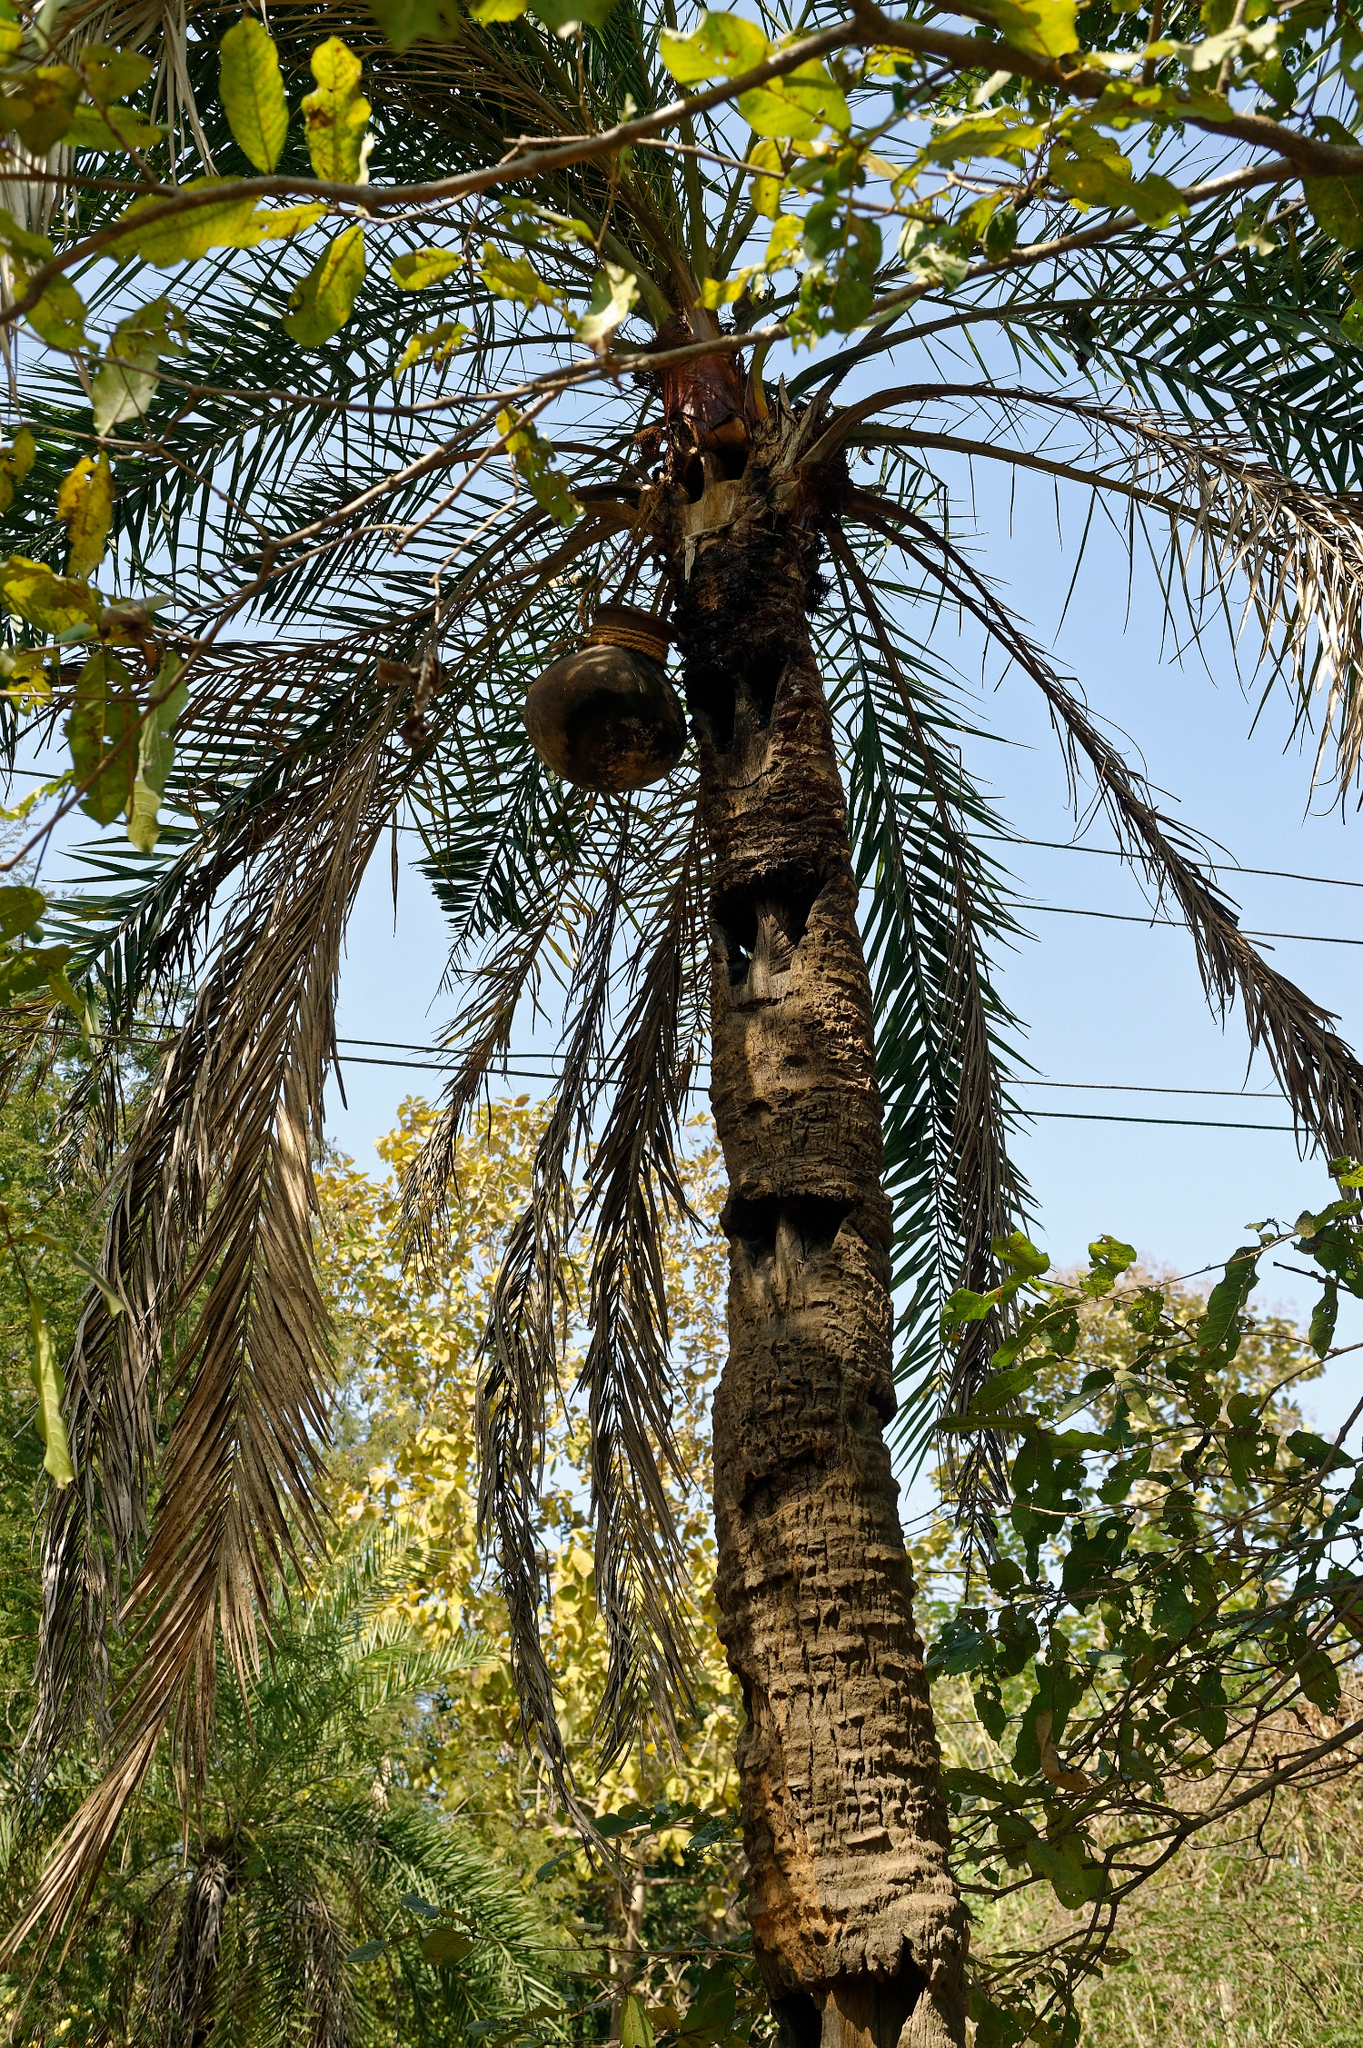Can you provide a story inspired by this image? Once upon a time, on the edge of a dense forest, stood an ancient palm tree, known to the locals as the 'Guardian of the Birds'. Its rough bark told tales of many seasons, and its leaves whispered secrets carried by the wind. Suspended from one of its sturdy branches was a birdhouse that had seen generations of feathered visitors. Every morning, the forest woke to the chirping melodies of birds greeting the day. The tree, with its arms stretched towards the sky, seemed to hold a sanctuary for all birdkind, offering them a safe haven amidst the sprawling canopy. This symbiotic relationship between the tree and the birds had fostered a sense of harmony and peace in the forest, where the trees and the creatures lived in mutual respect and care. 